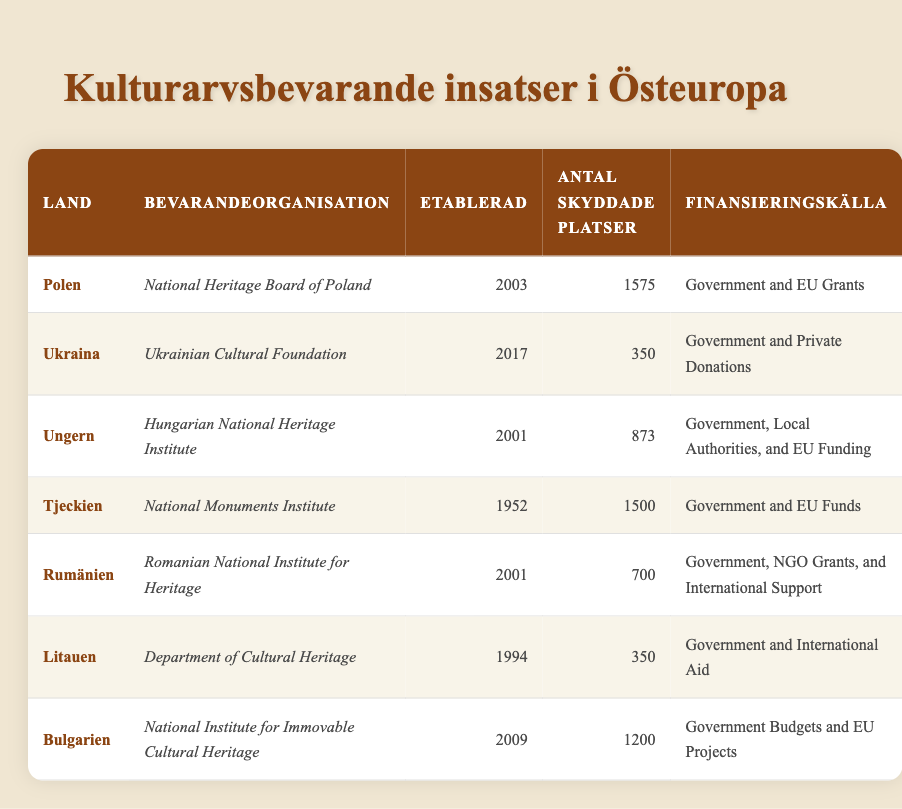What is the name of the preservation organization in Poland? The preservation organization in Poland is listed as "National Heritage Board of Poland."
Answer: National Heritage Board of Poland Which country established its preservation organization first? To find out which country established its organization first, we look at the "Established" column. The earliest year listed is 1952 for the Czech Republic.
Answer: Czech Republic How many sites are protected in Hungary? The number of sites protected in Hungary is specified in the table as 873.
Answer: 873 Which country has the most sites protected? We compare the "NumberOfSitesProtected" values across all countries. Poland has 1575 sites, which is greater than any other country listed.
Answer: Poland Is the Romanian National Institute for Heritage funded by private donations? The funding source for Romania's organization indicates it is supported by "Government, NGO Grants, and International Support," but does not specify private donations.
Answer: No What is the total number of sites protected across Lithuania and Ukraine? To calculate this, we add the number of sites protected in Lithuania (350) and Ukraine (350). This gives us a total of 700 sites.
Answer: 700 What are the main funding sources for preservation in Hungary? The table mentions that the funding sources for the Hungarian National Heritage Institute are "Government, Local Authorities, and EU Funding."
Answer: Government, Local Authorities, and EU Funding Is the "Department of Cultural Heritage" in Lithuania older than the "Ukrainian Cultural Foundation"? Lithuania's "Department of Cultural Heritage" was established in 1994, while Ukraine's organization was established in 2017. Since 1994 is earlier than 2017, the Lithuania organization is older.
Answer: Yes What is the average number of sites protected among these countries? To find the average, we sum the number of sites protected for each country: 1575 + 350 + 873 + 1500 + 700 + 350 + 1200 = 5,548. Then, we divide by 7 (the total number of countries) to get the average: 5,548 / 7 ≈ 792.57.
Answer: Approximately 792.57 